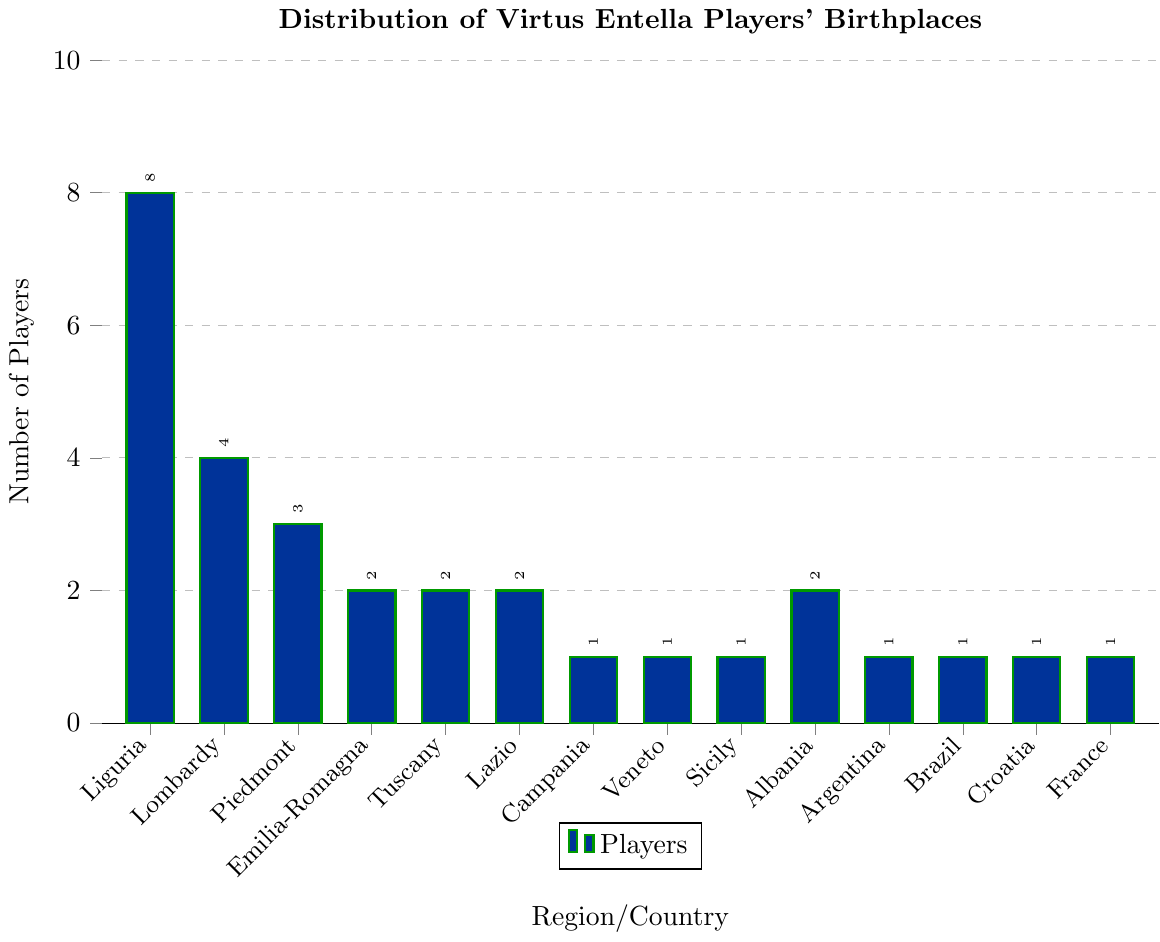Which region has the highest number of Virtus Entella players' birthplaces? The tallest bar corresponds to Liguria, indicating it has the highest number of players' birthplaces.
Answer: Liguria How many players are from foreign countries? Sum the number of players from Albania, Argentina, Brazil, Croatia, and France. This is 2 (Albania) + 1 (Argentina) + 1 (Brazil) + 1 (Croatia) + 1 (France) = 6.
Answer: 6 Compare the number of players from Liguria and Lombardy. Which has more and by how much? Liguria has 8 players while Lombardy has 4. The difference is 8 - 4 = 4.
Answer: Liguria by 4 What is the total number of players from Italian regions? Sum the number of players from all the Italian regions: 8 (Liguria) + 4 (Lombardy) + 3 (Piedmont) + 2 (Emilia-Romagna) + 2 (Tuscany) + 2 (Lazio) + 1 (Campania) + 1 (Veneto) + 1 (Sicily) = 24.
Answer: 24 Which foreign country has the same number of Virtus Entella players as Emilia-Romagna? Both Albania and Emilia-Romagna have the same number of players, which is 2.
Answer: Albania Are there more players from Liguria or from the combined total of Lazio and Tuscany? Liguria has 8 players. Lazio and Tuscany combined have 2 (Lazio) + 2 (Tuscany) = 4. Comparing 8 with 4, Liguria has more.
Answer: Liguria Which regions/countries have exactly 1 player? Identify all bars with a height of 1, which correspond to Campania, Veneto, Sicily, Argentina, Brazil, Croatia, and France.
Answer: Campania, Veneto, Sicily, Argentina, Brazil, Croatia, France What is the average number of players from Liguria, Lombardy, and Piedmont? Sum the number of players from these regions: 8 (Liguria) + 4 (Lombardy) + 3 (Piedmont) = 15. Divide by the number of regions: 15 / 3 = 5.
Answer: 5 How many players come from the top three regions in terms of birthplace? The top three regions are Liguria (8), Lombardy (4), and Piedmont (3). Sum their players: 8 + 4 + 3 = 15.
Answer: 15 